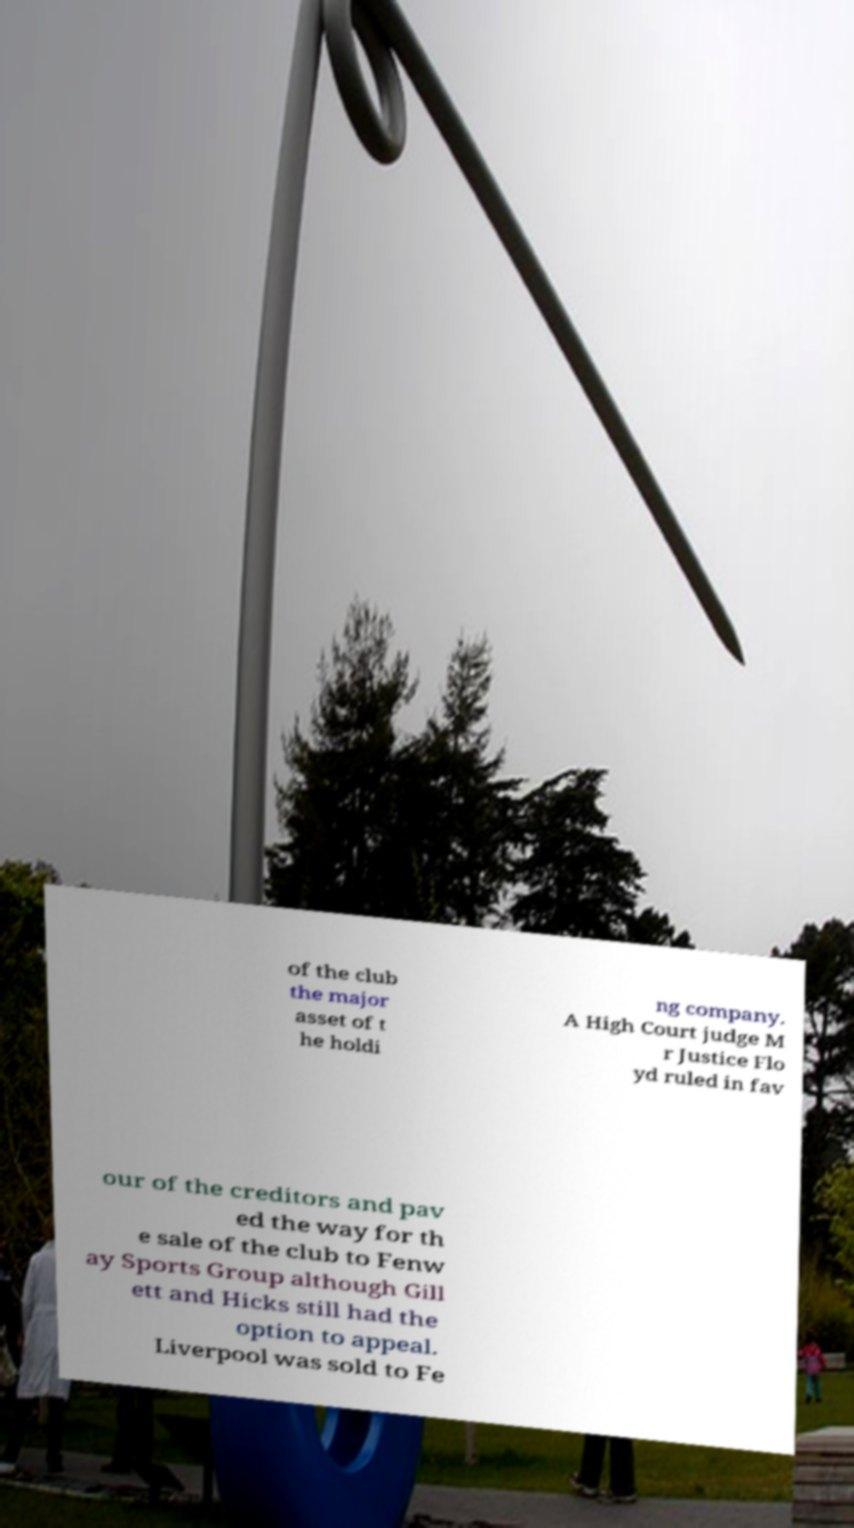Could you assist in decoding the text presented in this image and type it out clearly? of the club the major asset of t he holdi ng company. A High Court judge M r Justice Flo yd ruled in fav our of the creditors and pav ed the way for th e sale of the club to Fenw ay Sports Group although Gill ett and Hicks still had the option to appeal. Liverpool was sold to Fe 